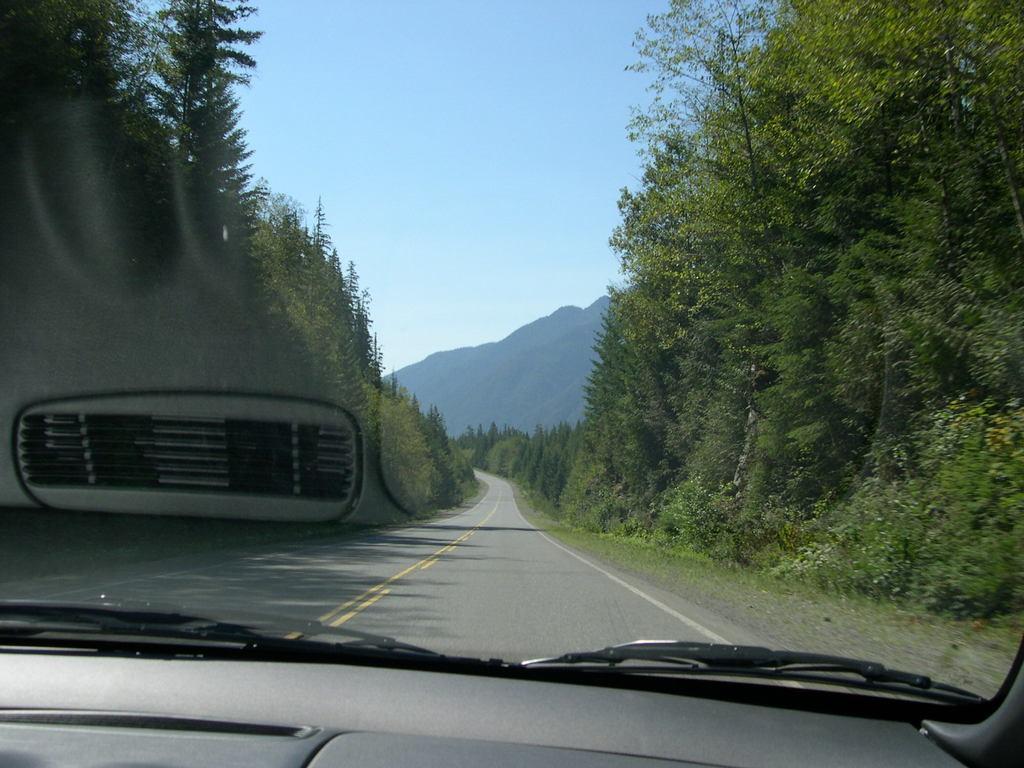Describe this image in one or two sentences. In this image in the foreground there is one vehicle and a window and through the window we could see some trees mountains and a walkway, and at the top of the image the sky. 